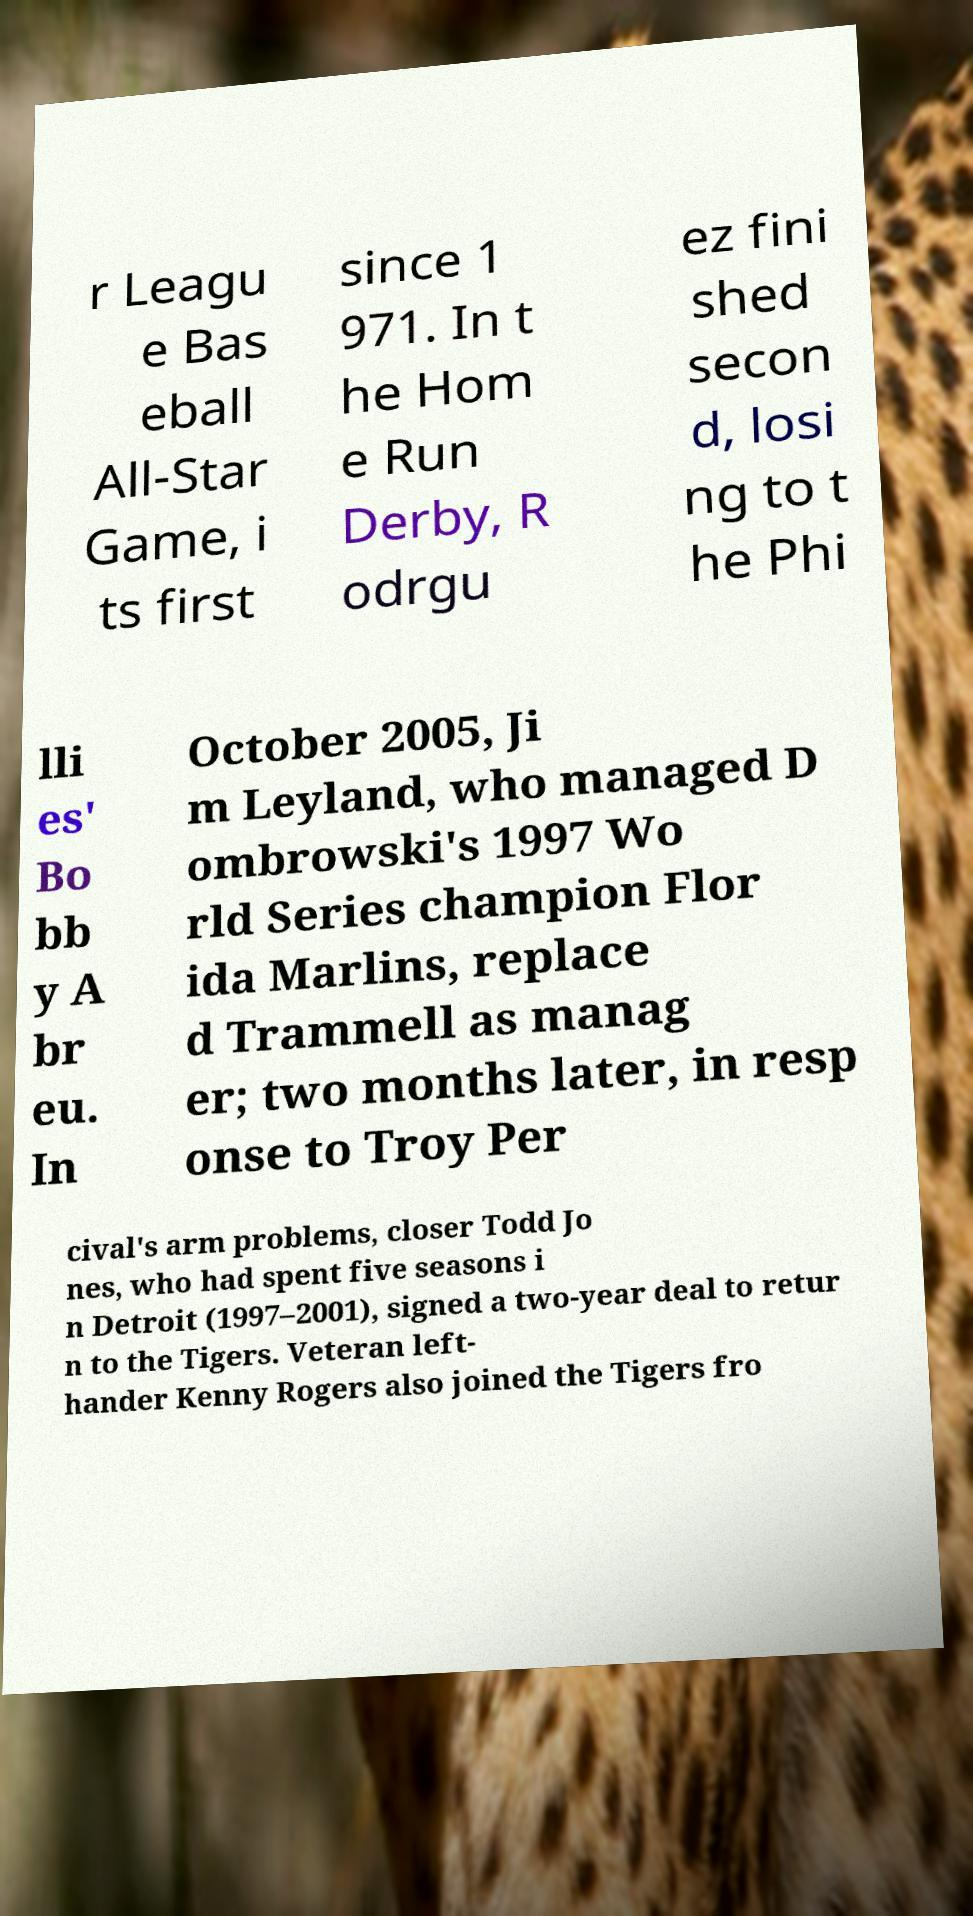Could you extract and type out the text from this image? r Leagu e Bas eball All-Star Game, i ts first since 1 971. In t he Hom e Run Derby, R odrgu ez fini shed secon d, losi ng to t he Phi lli es' Bo bb y A br eu. In October 2005, Ji m Leyland, who managed D ombrowski's 1997 Wo rld Series champion Flor ida Marlins, replace d Trammell as manag er; two months later, in resp onse to Troy Per cival's arm problems, closer Todd Jo nes, who had spent five seasons i n Detroit (1997–2001), signed a two-year deal to retur n to the Tigers. Veteran left- hander Kenny Rogers also joined the Tigers fro 